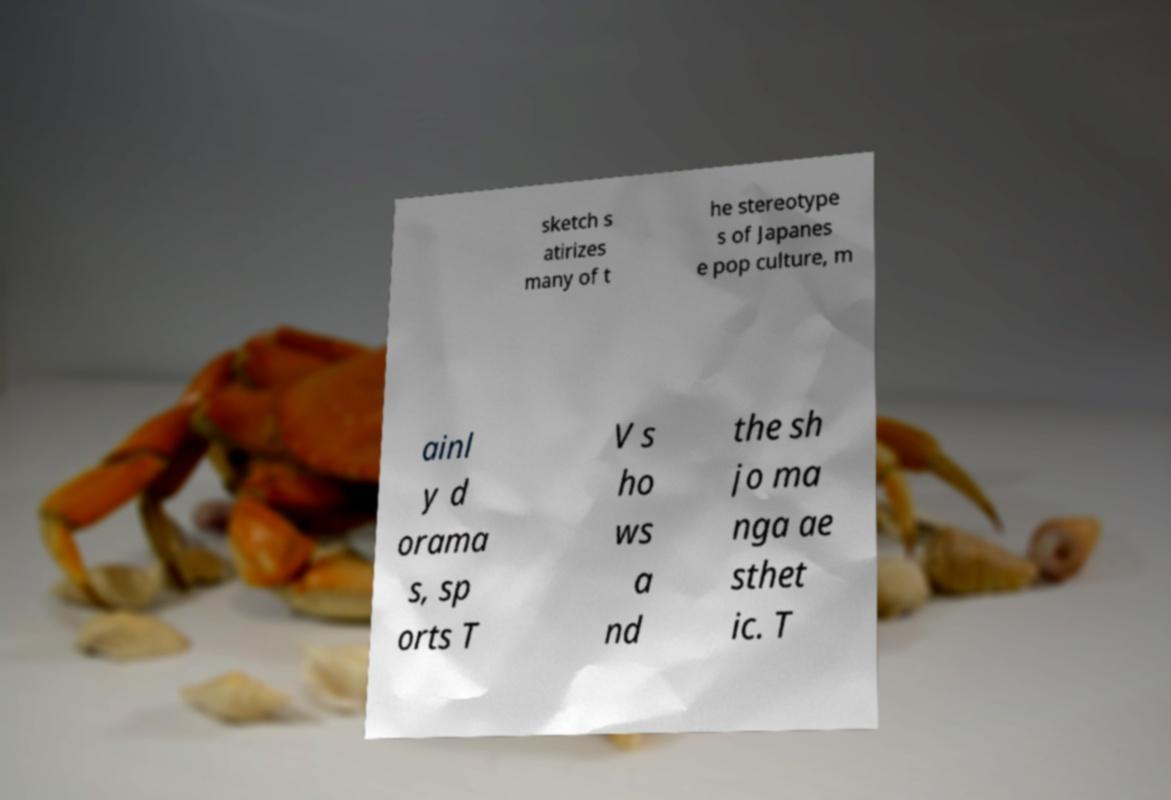Can you read and provide the text displayed in the image?This photo seems to have some interesting text. Can you extract and type it out for me? sketch s atirizes many of t he stereotype s of Japanes e pop culture, m ainl y d orama s, sp orts T V s ho ws a nd the sh jo ma nga ae sthet ic. T 